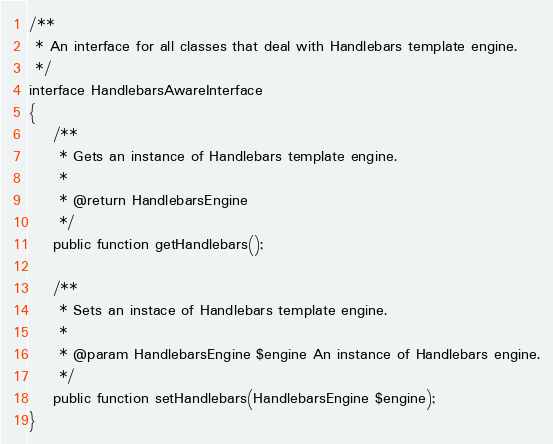Convert code to text. <code><loc_0><loc_0><loc_500><loc_500><_PHP_>
/**
 * An interface for all classes that deal with Handlebars template engine.
 */
interface HandlebarsAwareInterface
{
    /**
     * Gets an instance of Handlebars template engine.
     *
     * @return HandlebarsEngine
     */
    public function getHandlebars();

    /**
     * Sets an instace of Handlebars template engine.
     *
     * @param HandlebarsEngine $engine An instance of Handlebars engine.
     */
    public function setHandlebars(HandlebarsEngine $engine);
}
</code> 